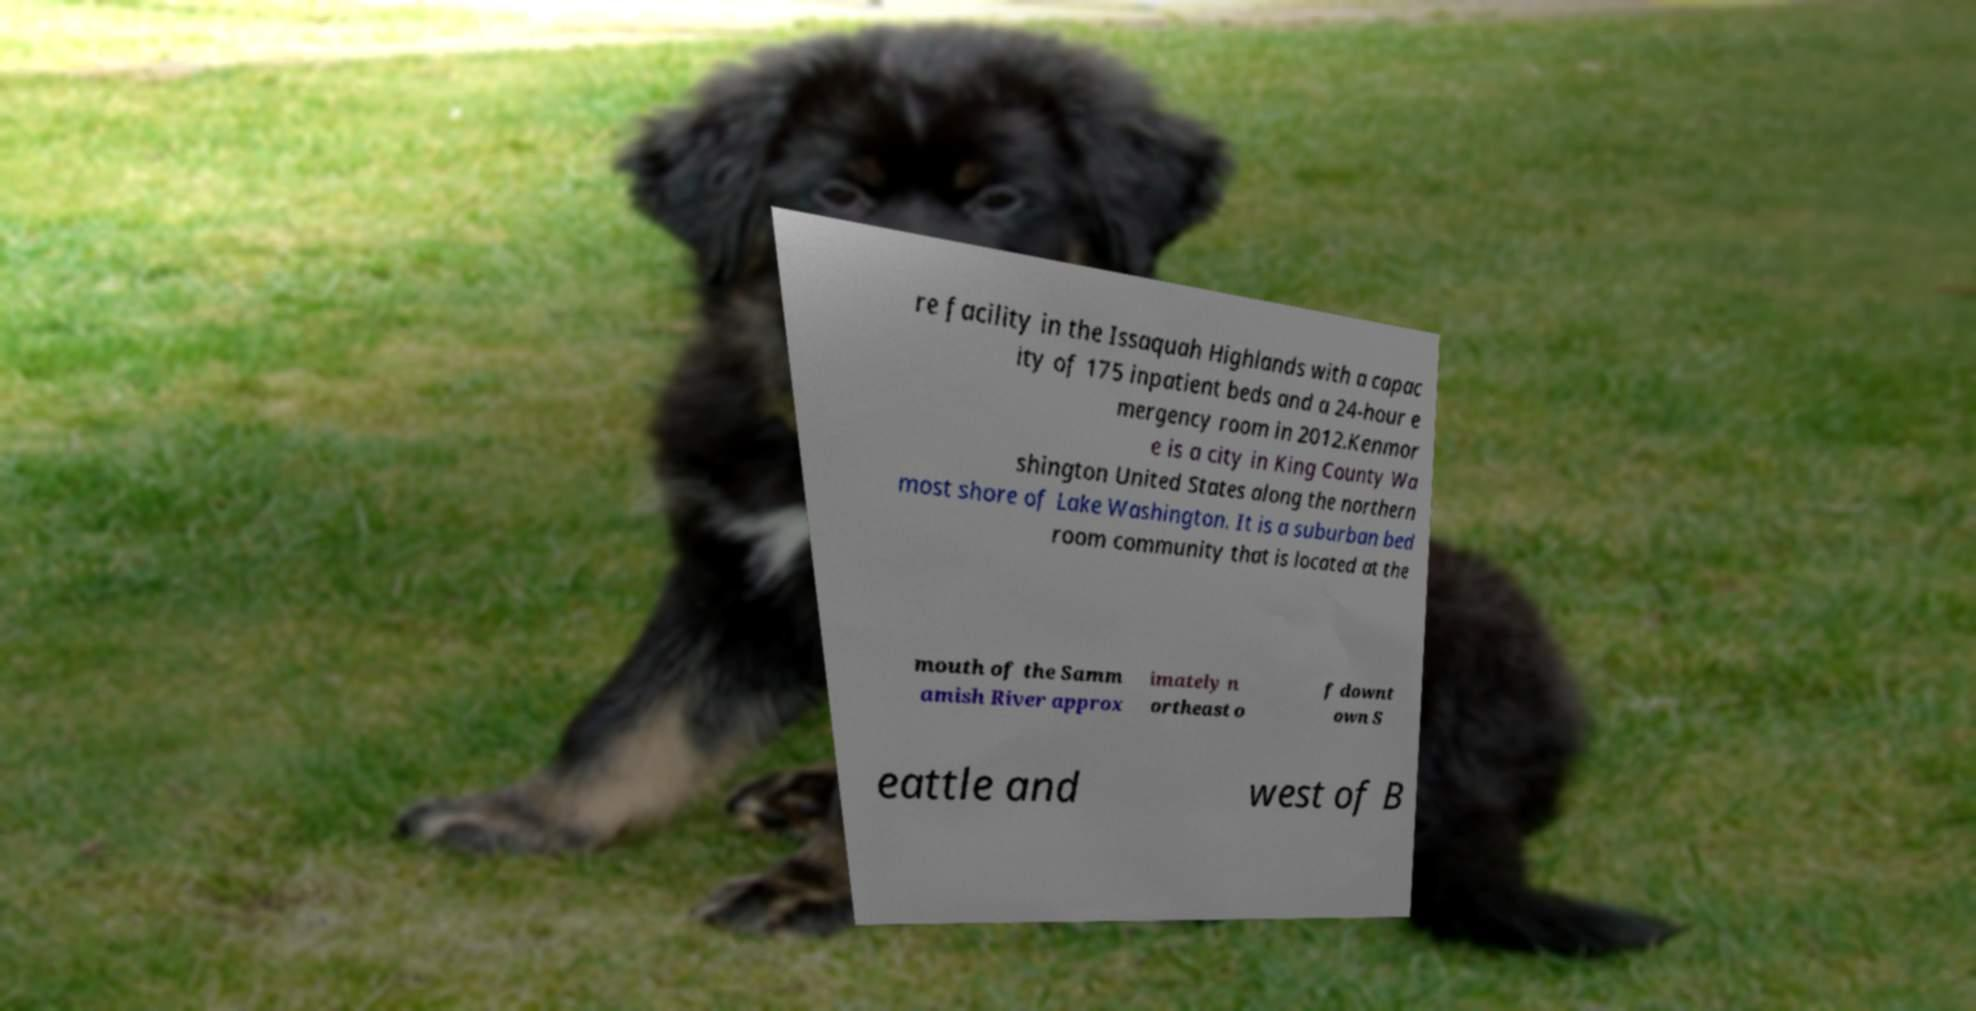Could you assist in decoding the text presented in this image and type it out clearly? re facility in the Issaquah Highlands with a capac ity of 175 inpatient beds and a 24-hour e mergency room in 2012.Kenmor e is a city in King County Wa shington United States along the northern most shore of Lake Washington. It is a suburban bed room community that is located at the mouth of the Samm amish River approx imately n ortheast o f downt own S eattle and west of B 